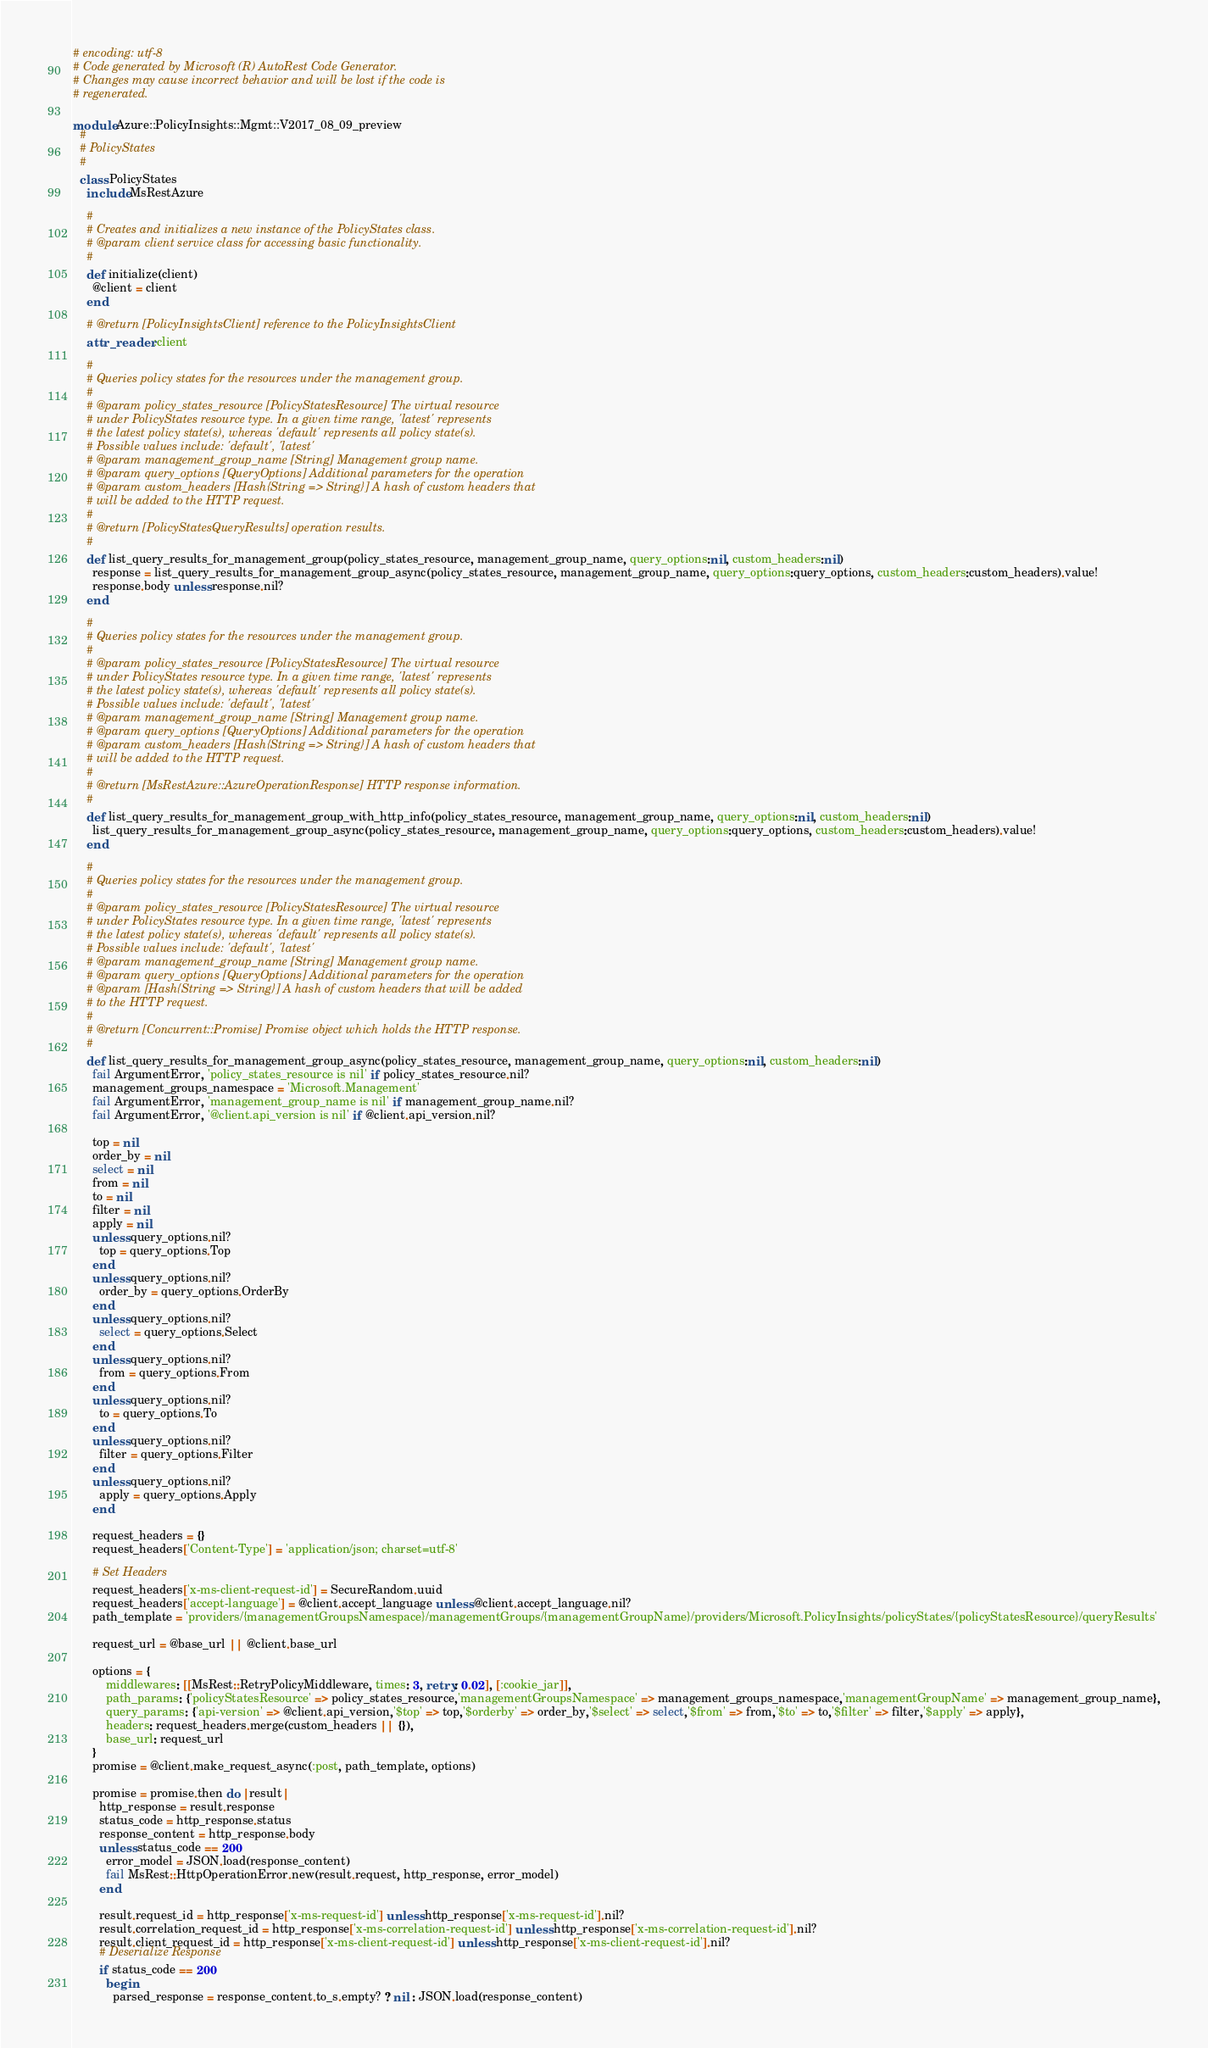Convert code to text. <code><loc_0><loc_0><loc_500><loc_500><_Ruby_># encoding: utf-8
# Code generated by Microsoft (R) AutoRest Code Generator.
# Changes may cause incorrect behavior and will be lost if the code is
# regenerated.

module Azure::PolicyInsights::Mgmt::V2017_08_09_preview
  #
  # PolicyStates
  #
  class PolicyStates
    include MsRestAzure

    #
    # Creates and initializes a new instance of the PolicyStates class.
    # @param client service class for accessing basic functionality.
    #
    def initialize(client)
      @client = client
    end

    # @return [PolicyInsightsClient] reference to the PolicyInsightsClient
    attr_reader :client

    #
    # Queries policy states for the resources under the management group.
    #
    # @param policy_states_resource [PolicyStatesResource] The virtual resource
    # under PolicyStates resource type. In a given time range, 'latest' represents
    # the latest policy state(s), whereas 'default' represents all policy state(s).
    # Possible values include: 'default', 'latest'
    # @param management_group_name [String] Management group name.
    # @param query_options [QueryOptions] Additional parameters for the operation
    # @param custom_headers [Hash{String => String}] A hash of custom headers that
    # will be added to the HTTP request.
    #
    # @return [PolicyStatesQueryResults] operation results.
    #
    def list_query_results_for_management_group(policy_states_resource, management_group_name, query_options:nil, custom_headers:nil)
      response = list_query_results_for_management_group_async(policy_states_resource, management_group_name, query_options:query_options, custom_headers:custom_headers).value!
      response.body unless response.nil?
    end

    #
    # Queries policy states for the resources under the management group.
    #
    # @param policy_states_resource [PolicyStatesResource] The virtual resource
    # under PolicyStates resource type. In a given time range, 'latest' represents
    # the latest policy state(s), whereas 'default' represents all policy state(s).
    # Possible values include: 'default', 'latest'
    # @param management_group_name [String] Management group name.
    # @param query_options [QueryOptions] Additional parameters for the operation
    # @param custom_headers [Hash{String => String}] A hash of custom headers that
    # will be added to the HTTP request.
    #
    # @return [MsRestAzure::AzureOperationResponse] HTTP response information.
    #
    def list_query_results_for_management_group_with_http_info(policy_states_resource, management_group_name, query_options:nil, custom_headers:nil)
      list_query_results_for_management_group_async(policy_states_resource, management_group_name, query_options:query_options, custom_headers:custom_headers).value!
    end

    #
    # Queries policy states for the resources under the management group.
    #
    # @param policy_states_resource [PolicyStatesResource] The virtual resource
    # under PolicyStates resource type. In a given time range, 'latest' represents
    # the latest policy state(s), whereas 'default' represents all policy state(s).
    # Possible values include: 'default', 'latest'
    # @param management_group_name [String] Management group name.
    # @param query_options [QueryOptions] Additional parameters for the operation
    # @param [Hash{String => String}] A hash of custom headers that will be added
    # to the HTTP request.
    #
    # @return [Concurrent::Promise] Promise object which holds the HTTP response.
    #
    def list_query_results_for_management_group_async(policy_states_resource, management_group_name, query_options:nil, custom_headers:nil)
      fail ArgumentError, 'policy_states_resource is nil' if policy_states_resource.nil?
      management_groups_namespace = 'Microsoft.Management'
      fail ArgumentError, 'management_group_name is nil' if management_group_name.nil?
      fail ArgumentError, '@client.api_version is nil' if @client.api_version.nil?

      top = nil
      order_by = nil
      select = nil
      from = nil
      to = nil
      filter = nil
      apply = nil
      unless query_options.nil?
        top = query_options.Top
      end
      unless query_options.nil?
        order_by = query_options.OrderBy
      end
      unless query_options.nil?
        select = query_options.Select
      end
      unless query_options.nil?
        from = query_options.From
      end
      unless query_options.nil?
        to = query_options.To
      end
      unless query_options.nil?
        filter = query_options.Filter
      end
      unless query_options.nil?
        apply = query_options.Apply
      end

      request_headers = {}
      request_headers['Content-Type'] = 'application/json; charset=utf-8'

      # Set Headers
      request_headers['x-ms-client-request-id'] = SecureRandom.uuid
      request_headers['accept-language'] = @client.accept_language unless @client.accept_language.nil?
      path_template = 'providers/{managementGroupsNamespace}/managementGroups/{managementGroupName}/providers/Microsoft.PolicyInsights/policyStates/{policyStatesResource}/queryResults'

      request_url = @base_url || @client.base_url

      options = {
          middlewares: [[MsRest::RetryPolicyMiddleware, times: 3, retry: 0.02], [:cookie_jar]],
          path_params: {'policyStatesResource' => policy_states_resource,'managementGroupsNamespace' => management_groups_namespace,'managementGroupName' => management_group_name},
          query_params: {'api-version' => @client.api_version,'$top' => top,'$orderby' => order_by,'$select' => select,'$from' => from,'$to' => to,'$filter' => filter,'$apply' => apply},
          headers: request_headers.merge(custom_headers || {}),
          base_url: request_url
      }
      promise = @client.make_request_async(:post, path_template, options)

      promise = promise.then do |result|
        http_response = result.response
        status_code = http_response.status
        response_content = http_response.body
        unless status_code == 200
          error_model = JSON.load(response_content)
          fail MsRest::HttpOperationError.new(result.request, http_response, error_model)
        end

        result.request_id = http_response['x-ms-request-id'] unless http_response['x-ms-request-id'].nil?
        result.correlation_request_id = http_response['x-ms-correlation-request-id'] unless http_response['x-ms-correlation-request-id'].nil?
        result.client_request_id = http_response['x-ms-client-request-id'] unless http_response['x-ms-client-request-id'].nil?
        # Deserialize Response
        if status_code == 200
          begin
            parsed_response = response_content.to_s.empty? ? nil : JSON.load(response_content)</code> 